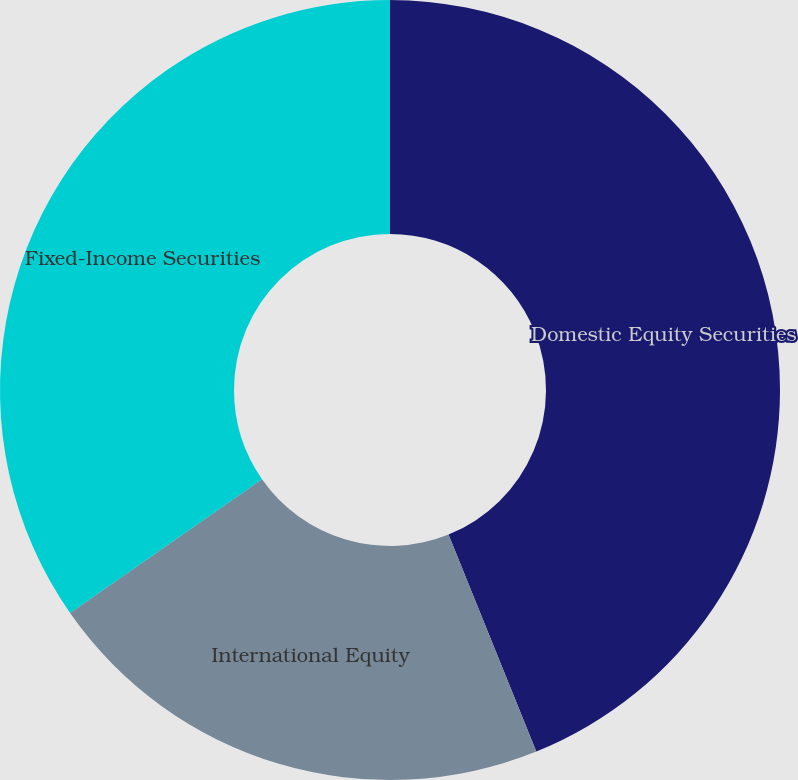Convert chart. <chart><loc_0><loc_0><loc_500><loc_500><pie_chart><fcel>Domestic Equity Securities<fcel>International Equity<fcel>Fixed-Income Securities<nl><fcel>43.88%<fcel>21.43%<fcel>34.69%<nl></chart> 